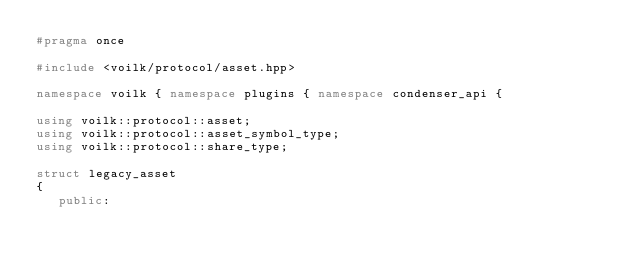Convert code to text. <code><loc_0><loc_0><loc_500><loc_500><_C++_>#pragma once

#include <voilk/protocol/asset.hpp>

namespace voilk { namespace plugins { namespace condenser_api {

using voilk::protocol::asset;
using voilk::protocol::asset_symbol_type;
using voilk::protocol::share_type;

struct legacy_asset
{
   public:</code> 